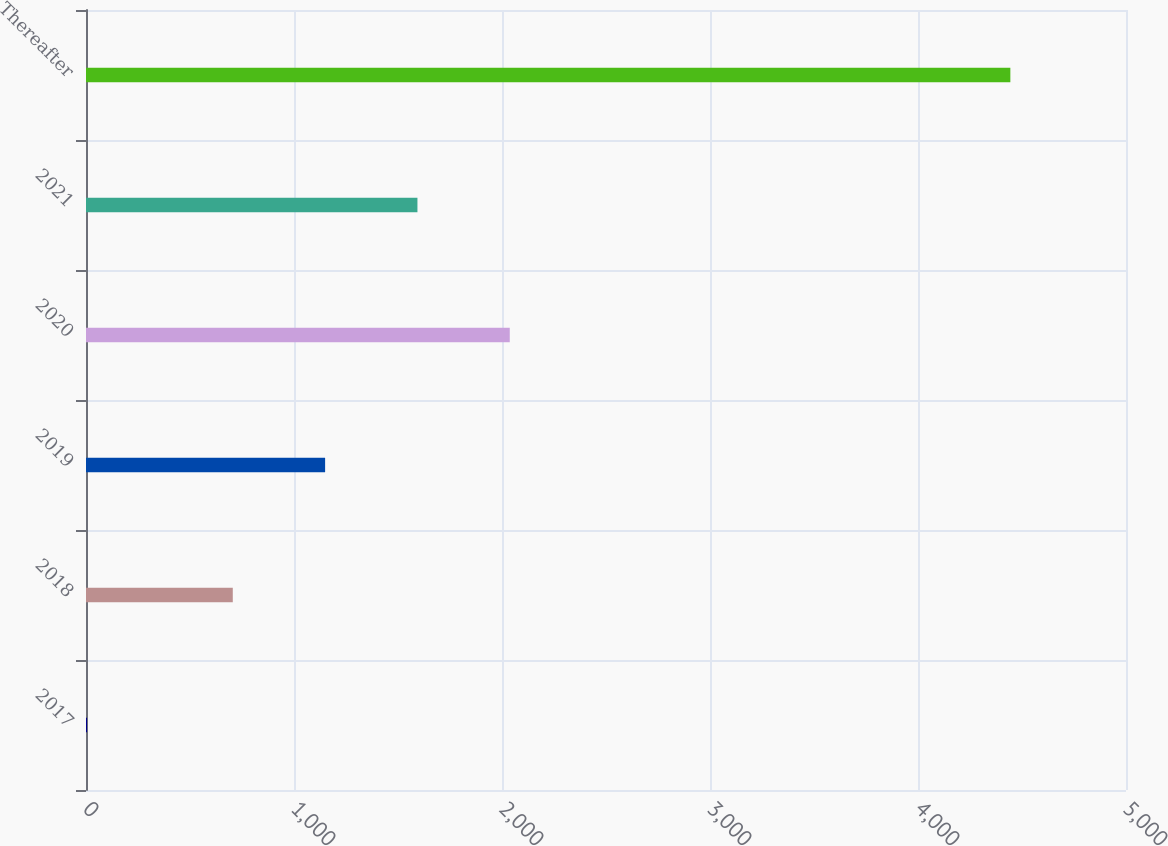<chart> <loc_0><loc_0><loc_500><loc_500><bar_chart><fcel>2017<fcel>2018<fcel>2019<fcel>2020<fcel>2021<fcel>Thereafter<nl><fcel>5.1<fcel>705.7<fcel>1149.59<fcel>2037.37<fcel>1593.48<fcel>4444<nl></chart> 